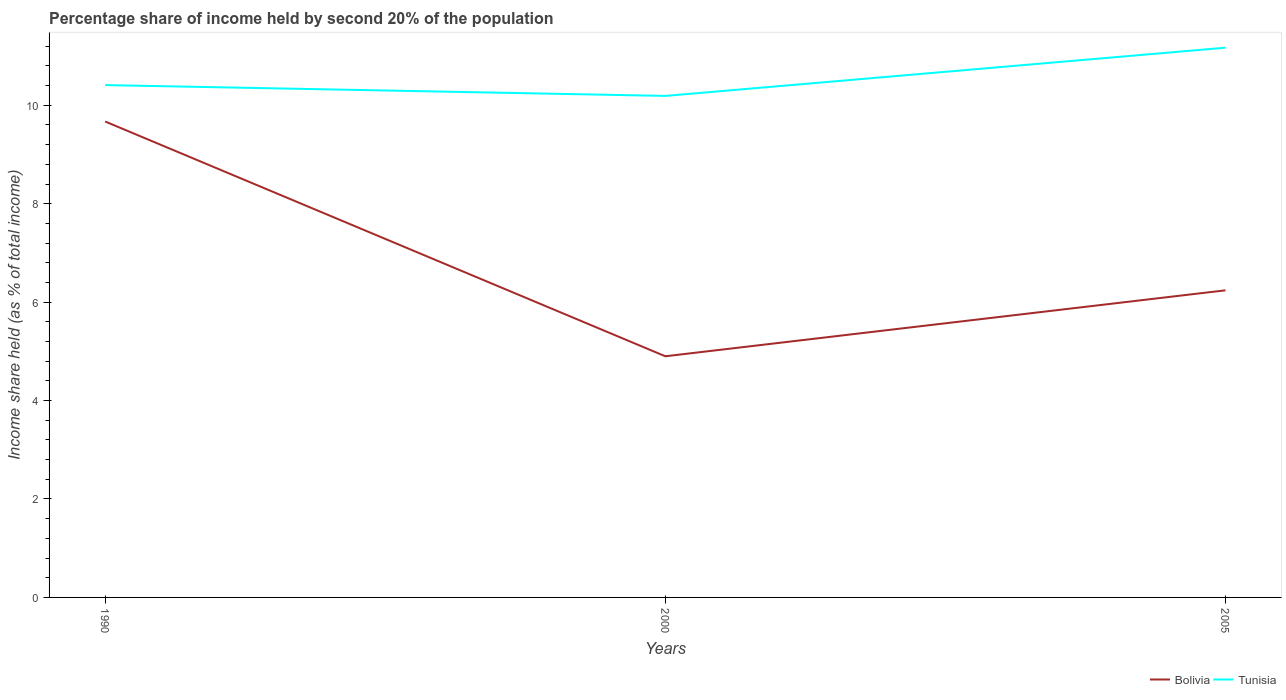How many different coloured lines are there?
Give a very brief answer. 2. Does the line corresponding to Tunisia intersect with the line corresponding to Bolivia?
Provide a short and direct response. No. Across all years, what is the maximum share of income held by second 20% of the population in Tunisia?
Give a very brief answer. 10.19. In which year was the share of income held by second 20% of the population in Tunisia maximum?
Offer a very short reply. 2000. What is the total share of income held by second 20% of the population in Bolivia in the graph?
Keep it short and to the point. 3.43. What is the difference between the highest and the second highest share of income held by second 20% of the population in Tunisia?
Your answer should be compact. 0.98. What is the difference between the highest and the lowest share of income held by second 20% of the population in Bolivia?
Keep it short and to the point. 1. What is the difference between two consecutive major ticks on the Y-axis?
Ensure brevity in your answer.  2. Are the values on the major ticks of Y-axis written in scientific E-notation?
Provide a short and direct response. No. Where does the legend appear in the graph?
Provide a succinct answer. Bottom right. How are the legend labels stacked?
Keep it short and to the point. Horizontal. What is the title of the graph?
Provide a short and direct response. Percentage share of income held by second 20% of the population. What is the label or title of the X-axis?
Your response must be concise. Years. What is the label or title of the Y-axis?
Offer a terse response. Income share held (as % of total income). What is the Income share held (as % of total income) in Bolivia in 1990?
Your answer should be compact. 9.67. What is the Income share held (as % of total income) in Tunisia in 1990?
Give a very brief answer. 10.41. What is the Income share held (as % of total income) in Bolivia in 2000?
Your response must be concise. 4.9. What is the Income share held (as % of total income) of Tunisia in 2000?
Your answer should be compact. 10.19. What is the Income share held (as % of total income) of Bolivia in 2005?
Offer a terse response. 6.24. What is the Income share held (as % of total income) in Tunisia in 2005?
Your response must be concise. 11.17. Across all years, what is the maximum Income share held (as % of total income) of Bolivia?
Provide a succinct answer. 9.67. Across all years, what is the maximum Income share held (as % of total income) in Tunisia?
Give a very brief answer. 11.17. Across all years, what is the minimum Income share held (as % of total income) of Bolivia?
Offer a very short reply. 4.9. Across all years, what is the minimum Income share held (as % of total income) in Tunisia?
Provide a succinct answer. 10.19. What is the total Income share held (as % of total income) of Bolivia in the graph?
Provide a short and direct response. 20.81. What is the total Income share held (as % of total income) in Tunisia in the graph?
Your response must be concise. 31.77. What is the difference between the Income share held (as % of total income) of Bolivia in 1990 and that in 2000?
Keep it short and to the point. 4.77. What is the difference between the Income share held (as % of total income) of Tunisia in 1990 and that in 2000?
Provide a succinct answer. 0.22. What is the difference between the Income share held (as % of total income) of Bolivia in 1990 and that in 2005?
Provide a short and direct response. 3.43. What is the difference between the Income share held (as % of total income) of Tunisia in 1990 and that in 2005?
Give a very brief answer. -0.76. What is the difference between the Income share held (as % of total income) in Bolivia in 2000 and that in 2005?
Ensure brevity in your answer.  -1.34. What is the difference between the Income share held (as % of total income) in Tunisia in 2000 and that in 2005?
Your answer should be very brief. -0.98. What is the difference between the Income share held (as % of total income) in Bolivia in 1990 and the Income share held (as % of total income) in Tunisia in 2000?
Offer a very short reply. -0.52. What is the difference between the Income share held (as % of total income) in Bolivia in 1990 and the Income share held (as % of total income) in Tunisia in 2005?
Keep it short and to the point. -1.5. What is the difference between the Income share held (as % of total income) of Bolivia in 2000 and the Income share held (as % of total income) of Tunisia in 2005?
Keep it short and to the point. -6.27. What is the average Income share held (as % of total income) in Bolivia per year?
Provide a short and direct response. 6.94. What is the average Income share held (as % of total income) of Tunisia per year?
Keep it short and to the point. 10.59. In the year 1990, what is the difference between the Income share held (as % of total income) in Bolivia and Income share held (as % of total income) in Tunisia?
Provide a short and direct response. -0.74. In the year 2000, what is the difference between the Income share held (as % of total income) of Bolivia and Income share held (as % of total income) of Tunisia?
Keep it short and to the point. -5.29. In the year 2005, what is the difference between the Income share held (as % of total income) of Bolivia and Income share held (as % of total income) of Tunisia?
Give a very brief answer. -4.93. What is the ratio of the Income share held (as % of total income) in Bolivia in 1990 to that in 2000?
Keep it short and to the point. 1.97. What is the ratio of the Income share held (as % of total income) in Tunisia in 1990 to that in 2000?
Your answer should be compact. 1.02. What is the ratio of the Income share held (as % of total income) in Bolivia in 1990 to that in 2005?
Make the answer very short. 1.55. What is the ratio of the Income share held (as % of total income) of Tunisia in 1990 to that in 2005?
Provide a succinct answer. 0.93. What is the ratio of the Income share held (as % of total income) in Bolivia in 2000 to that in 2005?
Offer a terse response. 0.79. What is the ratio of the Income share held (as % of total income) in Tunisia in 2000 to that in 2005?
Your answer should be very brief. 0.91. What is the difference between the highest and the second highest Income share held (as % of total income) of Bolivia?
Make the answer very short. 3.43. What is the difference between the highest and the second highest Income share held (as % of total income) in Tunisia?
Offer a very short reply. 0.76. What is the difference between the highest and the lowest Income share held (as % of total income) in Bolivia?
Keep it short and to the point. 4.77. 